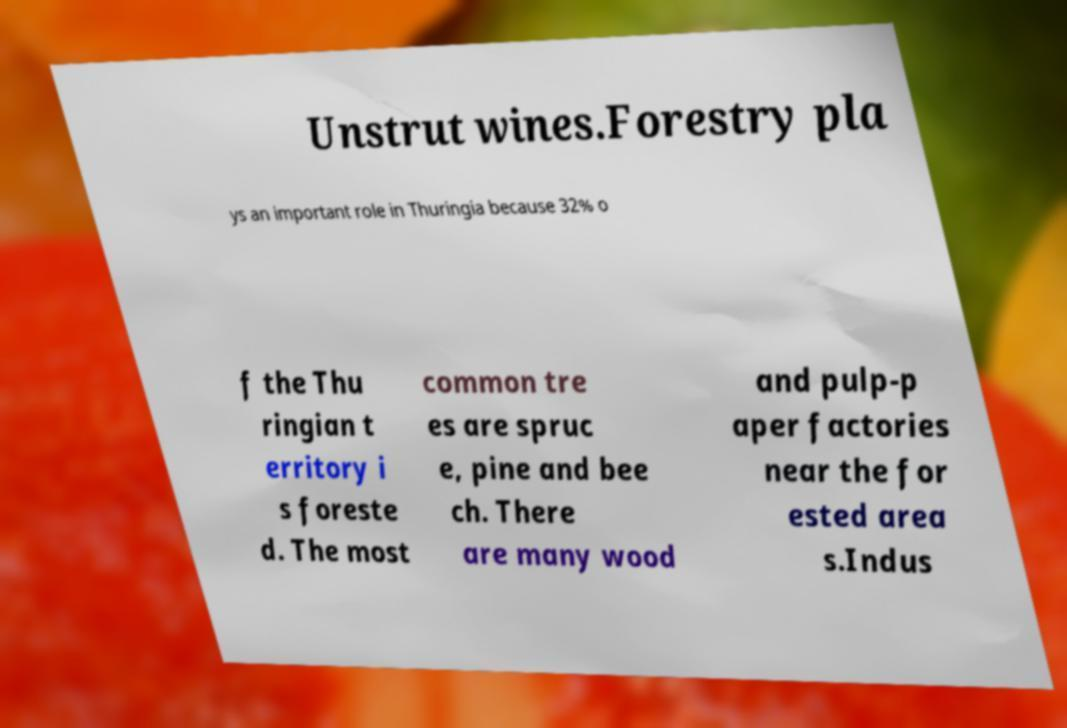Can you read and provide the text displayed in the image?This photo seems to have some interesting text. Can you extract and type it out for me? Unstrut wines.Forestry pla ys an important role in Thuringia because 32% o f the Thu ringian t erritory i s foreste d. The most common tre es are spruc e, pine and bee ch. There are many wood and pulp-p aper factories near the for ested area s.Indus 